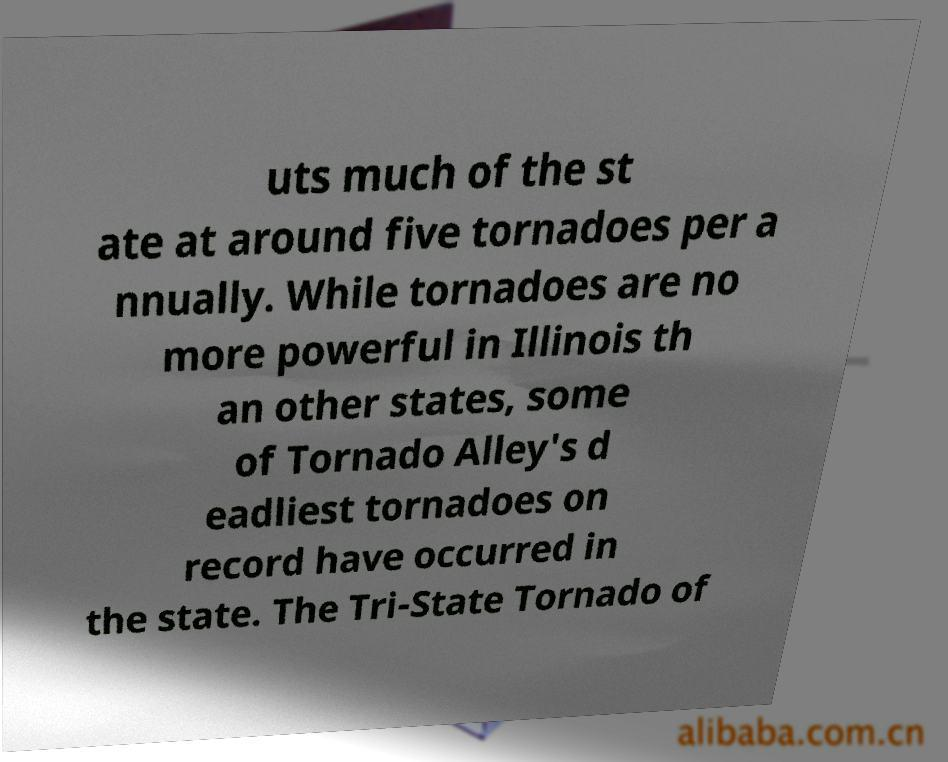There's text embedded in this image that I need extracted. Can you transcribe it verbatim? uts much of the st ate at around five tornadoes per a nnually. While tornadoes are no more powerful in Illinois th an other states, some of Tornado Alley's d eadliest tornadoes on record have occurred in the state. The Tri-State Tornado of 